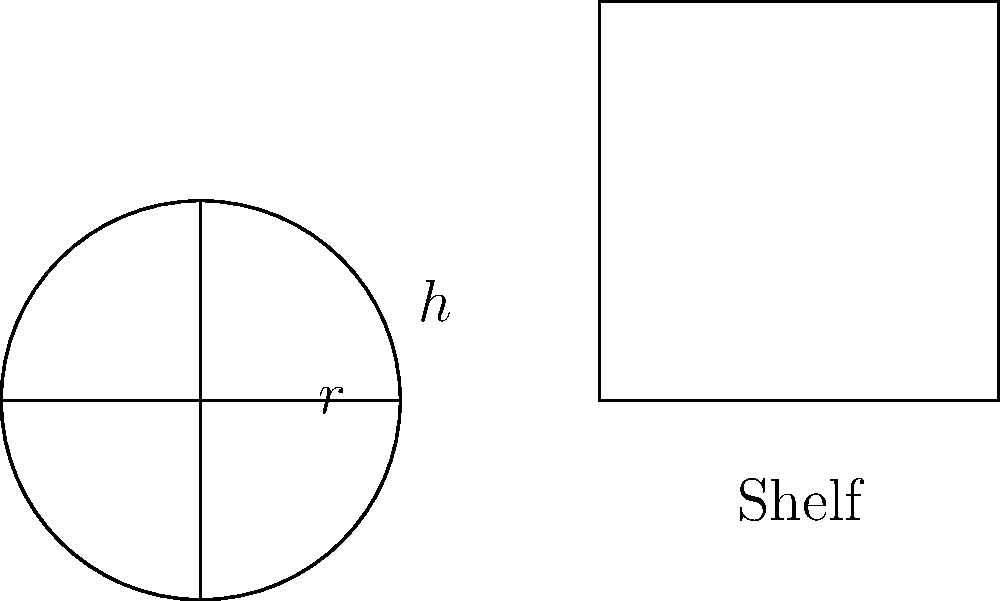You have cylindrical tea containers with a radius of 5 cm and a height of 15 cm. Your tea house shelves are 60 cm wide and 30 cm deep. What is the maximum number of tea containers you can fit on a single shelf, and what percentage of the shelf's volume is utilized? Let's approach this step-by-step:

1) First, calculate the volume of a single tea container:
   $V_{container} = \pi r^2 h = \pi \cdot 5^2 \cdot 15 = 1178.10$ cm³

2) Calculate the shelf's volume:
   $V_{shelf} = 60 \cdot 30 \cdot 15 = 27000$ cm³
   (We use 15 cm height, same as the containers, for fair volume comparison)

3) Determine how many containers fit along the width:
   $60 \div (2 \cdot 5) = 6$ containers

4) Determine how many containers fit along the depth:
   $30 \div (2 \cdot 5) = 3$ containers

5) Total number of containers:
   $6 \cdot 3 = 18$ containers

6) Calculate the total volume of 18 containers:
   $18 \cdot 1178.10 = 21205.80$ cm³

7) Calculate the percentage of shelf volume utilized:
   $(21205.80 \div 27000) \cdot 100 = 78.54\%$
Answer: 18 containers, 78.54% utilized 